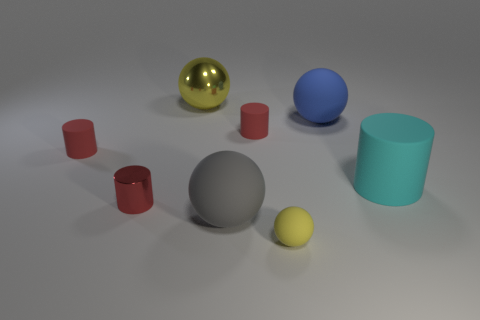Subtract all brown spheres. How many red cylinders are left? 3 Subtract all brown balls. Subtract all red cylinders. How many balls are left? 4 Add 1 red rubber objects. How many objects exist? 9 Add 8 yellow rubber spheres. How many yellow rubber spheres exist? 9 Subtract 1 yellow balls. How many objects are left? 7 Subtract all small red objects. Subtract all small yellow rubber balls. How many objects are left? 4 Add 4 blue objects. How many blue objects are left? 5 